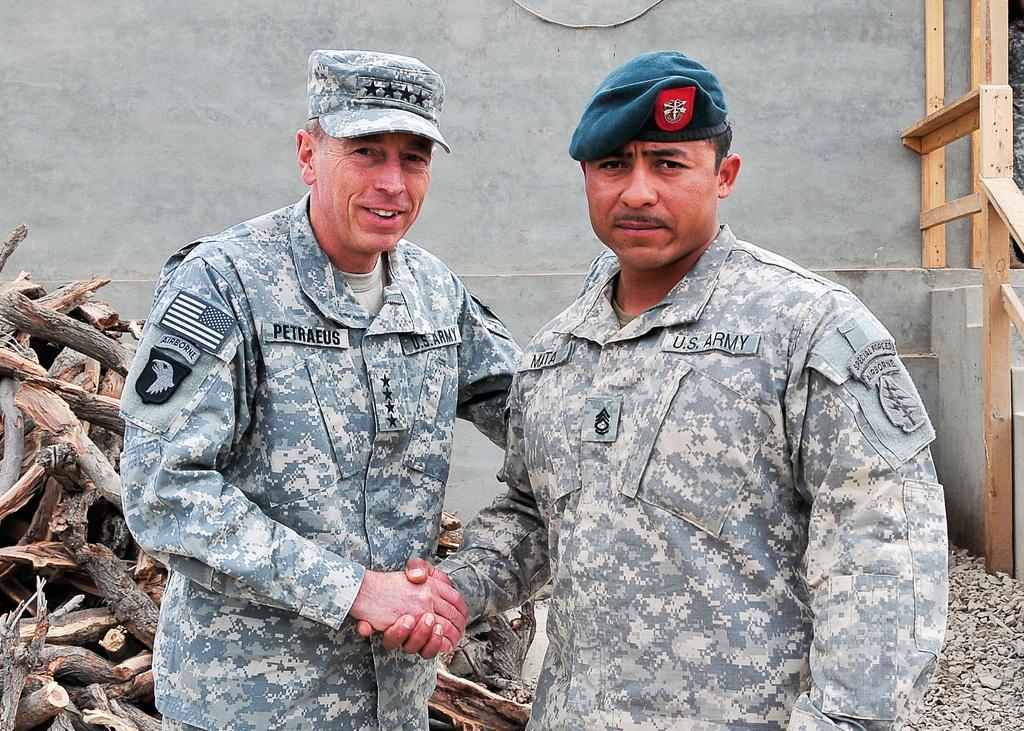How would you summarize this image in a sentence or two? In the center of the picture there are two soldiers shaking hands. On the left there are wooden logs. On the right there are stones, staircase and wooden hand railing. In the background it is a wall. 